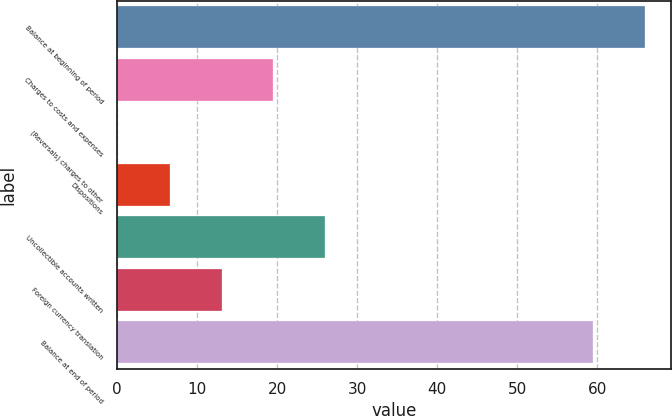Convert chart. <chart><loc_0><loc_0><loc_500><loc_500><bar_chart><fcel>Balance at beginning of period<fcel>Charges to costs and expenses<fcel>(Reversals) charges to other<fcel>Dispositions<fcel>Uncollectible accounts written<fcel>Foreign currency translation<fcel>Balance at end of period<nl><fcel>65.98<fcel>19.54<fcel>0.1<fcel>6.58<fcel>26.02<fcel>13.06<fcel>59.5<nl></chart> 